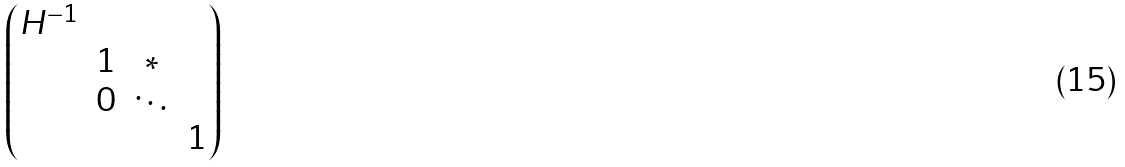<formula> <loc_0><loc_0><loc_500><loc_500>\begin{pmatrix} H ^ { - 1 } & & & \\ & 1 & * & \\ & 0 & \ddots & \\ & & & 1 \end{pmatrix}</formula> 